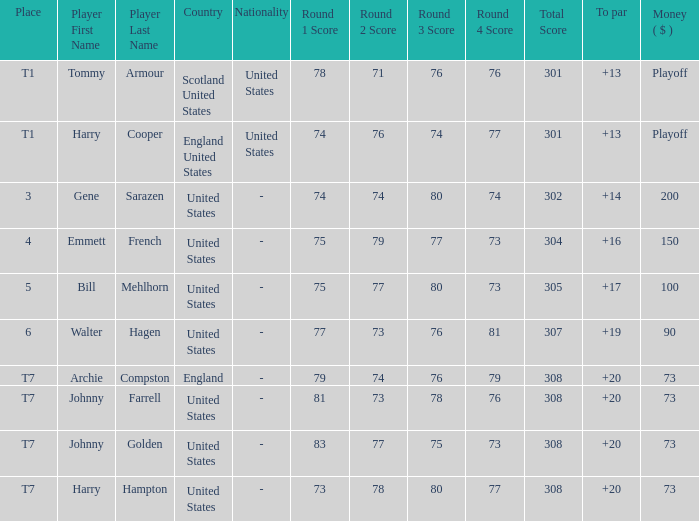What is the standing of the united states when the cash is $200? 3.0. 